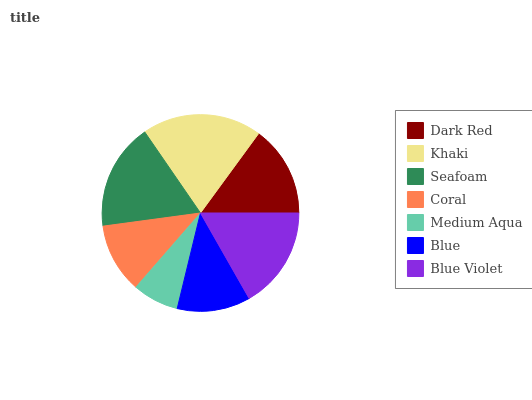Is Medium Aqua the minimum?
Answer yes or no. Yes. Is Khaki the maximum?
Answer yes or no. Yes. Is Seafoam the minimum?
Answer yes or no. No. Is Seafoam the maximum?
Answer yes or no. No. Is Khaki greater than Seafoam?
Answer yes or no. Yes. Is Seafoam less than Khaki?
Answer yes or no. Yes. Is Seafoam greater than Khaki?
Answer yes or no. No. Is Khaki less than Seafoam?
Answer yes or no. No. Is Dark Red the high median?
Answer yes or no. Yes. Is Dark Red the low median?
Answer yes or no. Yes. Is Seafoam the high median?
Answer yes or no. No. Is Blue the low median?
Answer yes or no. No. 